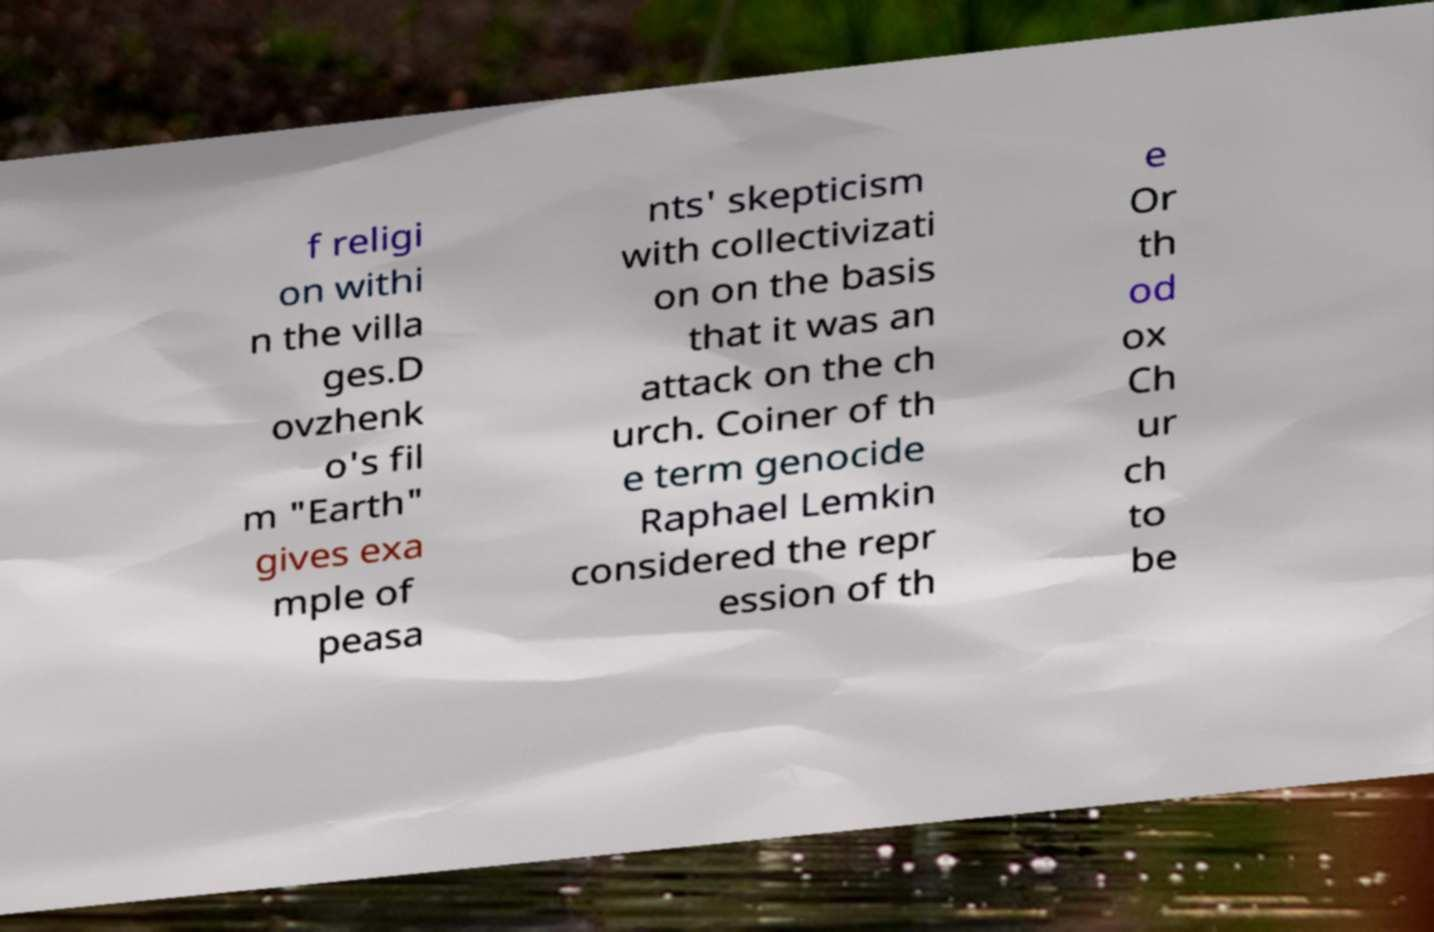Can you read and provide the text displayed in the image?This photo seems to have some interesting text. Can you extract and type it out for me? f religi on withi n the villa ges.D ovzhenk o's fil m "Earth" gives exa mple of peasa nts' skepticism with collectivizati on on the basis that it was an attack on the ch urch. Coiner of th e term genocide Raphael Lemkin considered the repr ession of th e Or th od ox Ch ur ch to be 